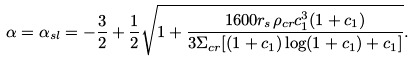Convert formula to latex. <formula><loc_0><loc_0><loc_500><loc_500>\alpha = \alpha _ { s l } = - \frac { 3 } { 2 } + \frac { 1 } { 2 } \sqrt { 1 + \frac { 1 6 0 0 r _ { s } \rho _ { c r } c _ { 1 } ^ { 3 } ( 1 + c _ { 1 } ) } { 3 \Sigma _ { c r } [ ( 1 + c _ { 1 } ) \log ( 1 + c _ { 1 } ) + c _ { 1 } ] } } .</formula> 